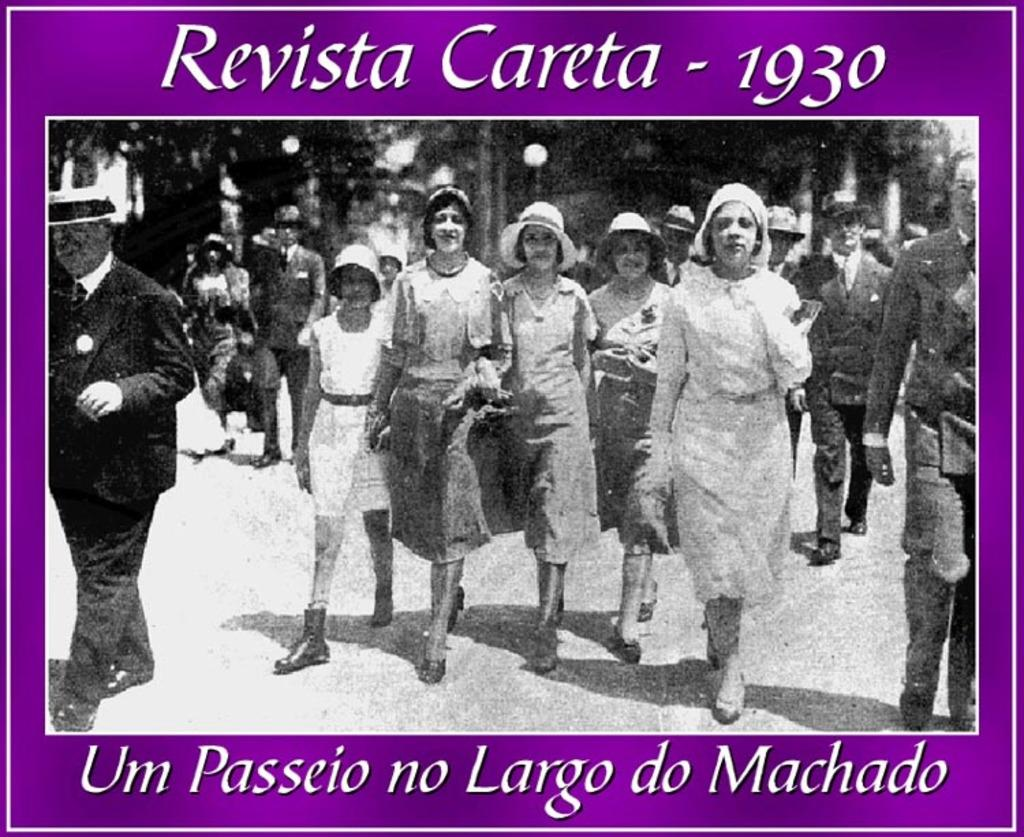What is the color scheme of the image? The image is black and white. What are the people in the image doing? The people in the image are walking. What can be seen under the people's feet in the image? The ground is visible in the image. What type of natural vegetation is present in the image? There are trees in the image. What type of man-made structures are visible in the image? There are houses in the image. What is written on the image? Text is written at the top and bottom of the image. How many beds can be seen in the image? There are no beds present in the image. What type of sense is being used by the people in the image? The image does not provide information about the senses being used by the people. 